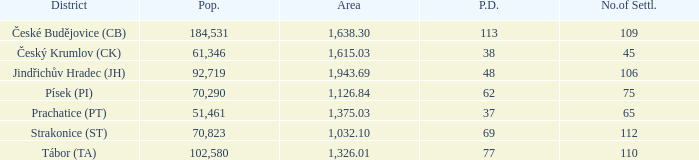What is the population density of the area with a population larger than 92,719? 2.0. 